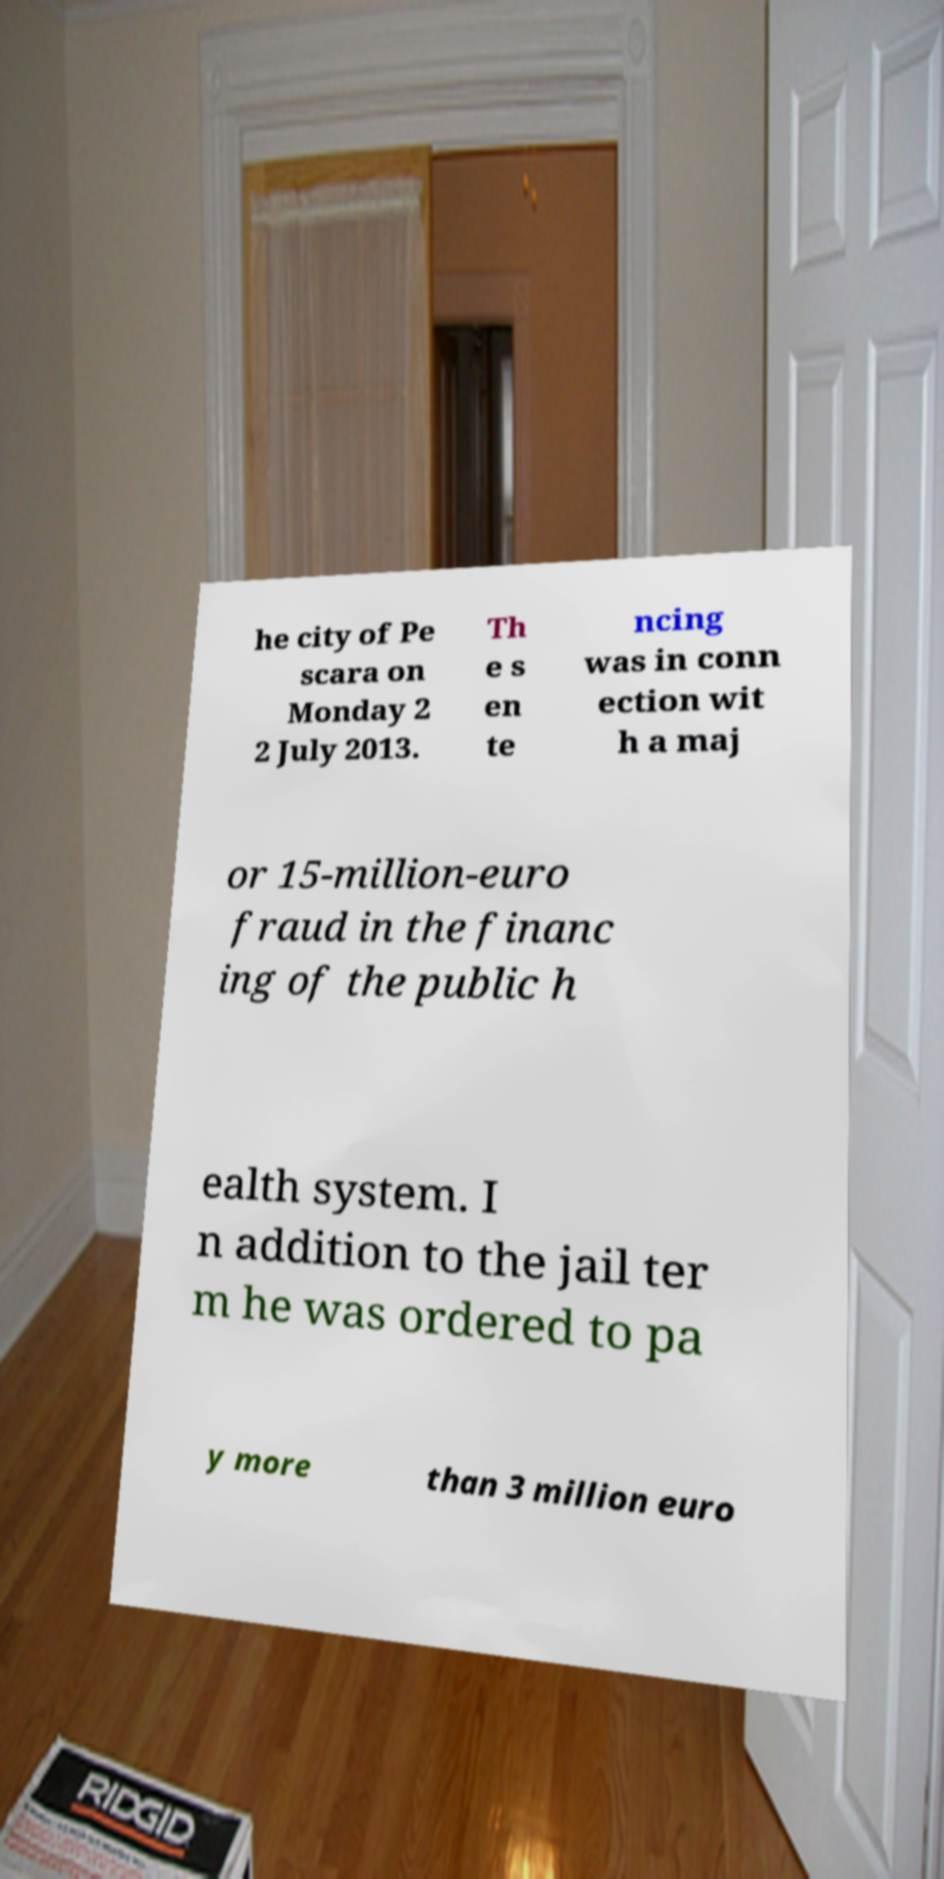Please identify and transcribe the text found in this image. he city of Pe scara on Monday 2 2 July 2013. Th e s en te ncing was in conn ection wit h a maj or 15-million-euro fraud in the financ ing of the public h ealth system. I n addition to the jail ter m he was ordered to pa y more than 3 million euro 